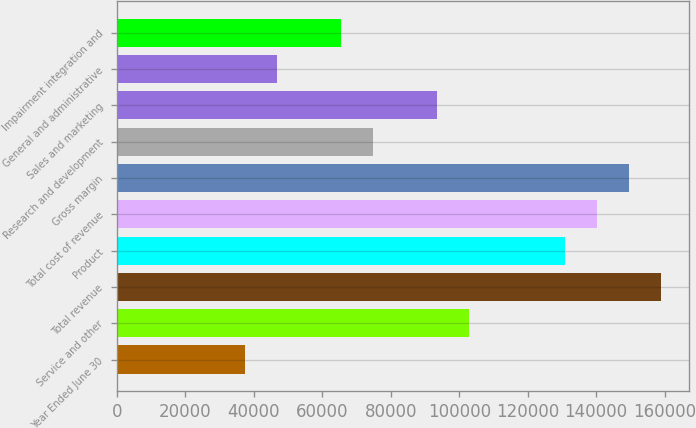Convert chart. <chart><loc_0><loc_0><loc_500><loc_500><bar_chart><fcel>Year Ended June 30<fcel>Service and other<fcel>Total revenue<fcel>Product<fcel>Total cost of revenue<fcel>Gross margin<fcel>Research and development<fcel>Sales and marketing<fcel>General and administrative<fcel>Impairment integration and<nl><fcel>37432.8<fcel>102938<fcel>159085<fcel>131012<fcel>140369<fcel>149727<fcel>74864.3<fcel>93580<fcel>46790.6<fcel>65506.4<nl></chart> 